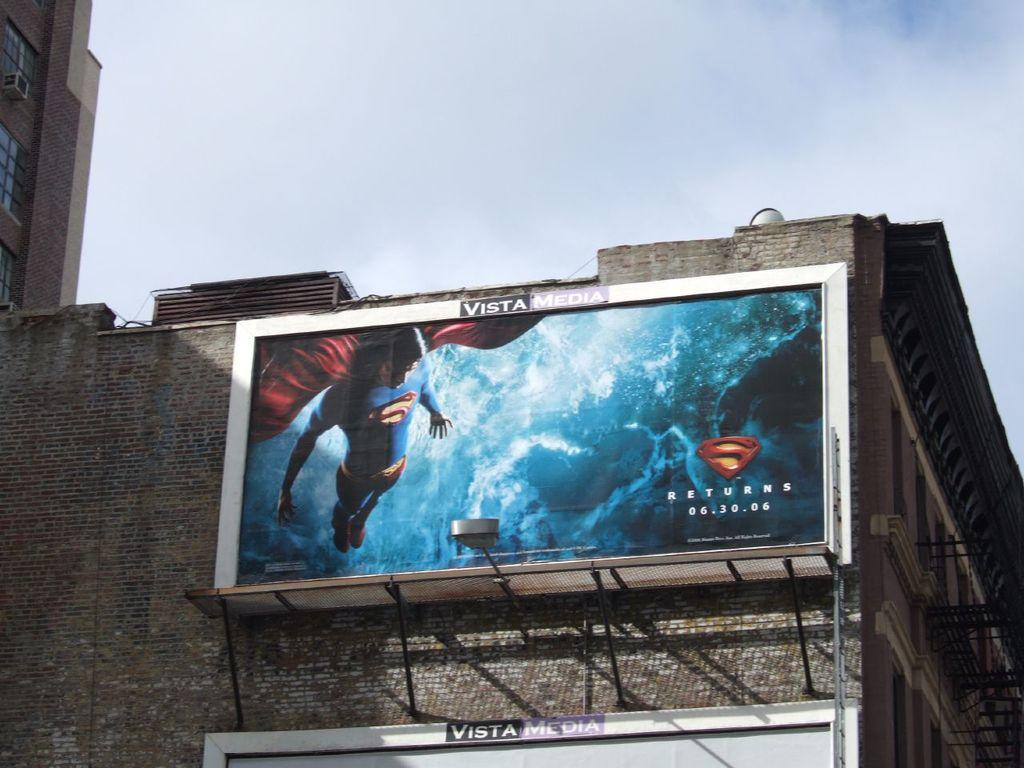Provide a one-sentence caption for the provided image. A big billboard sign advertising the movie Superman Returns, starting 06.30.06. 